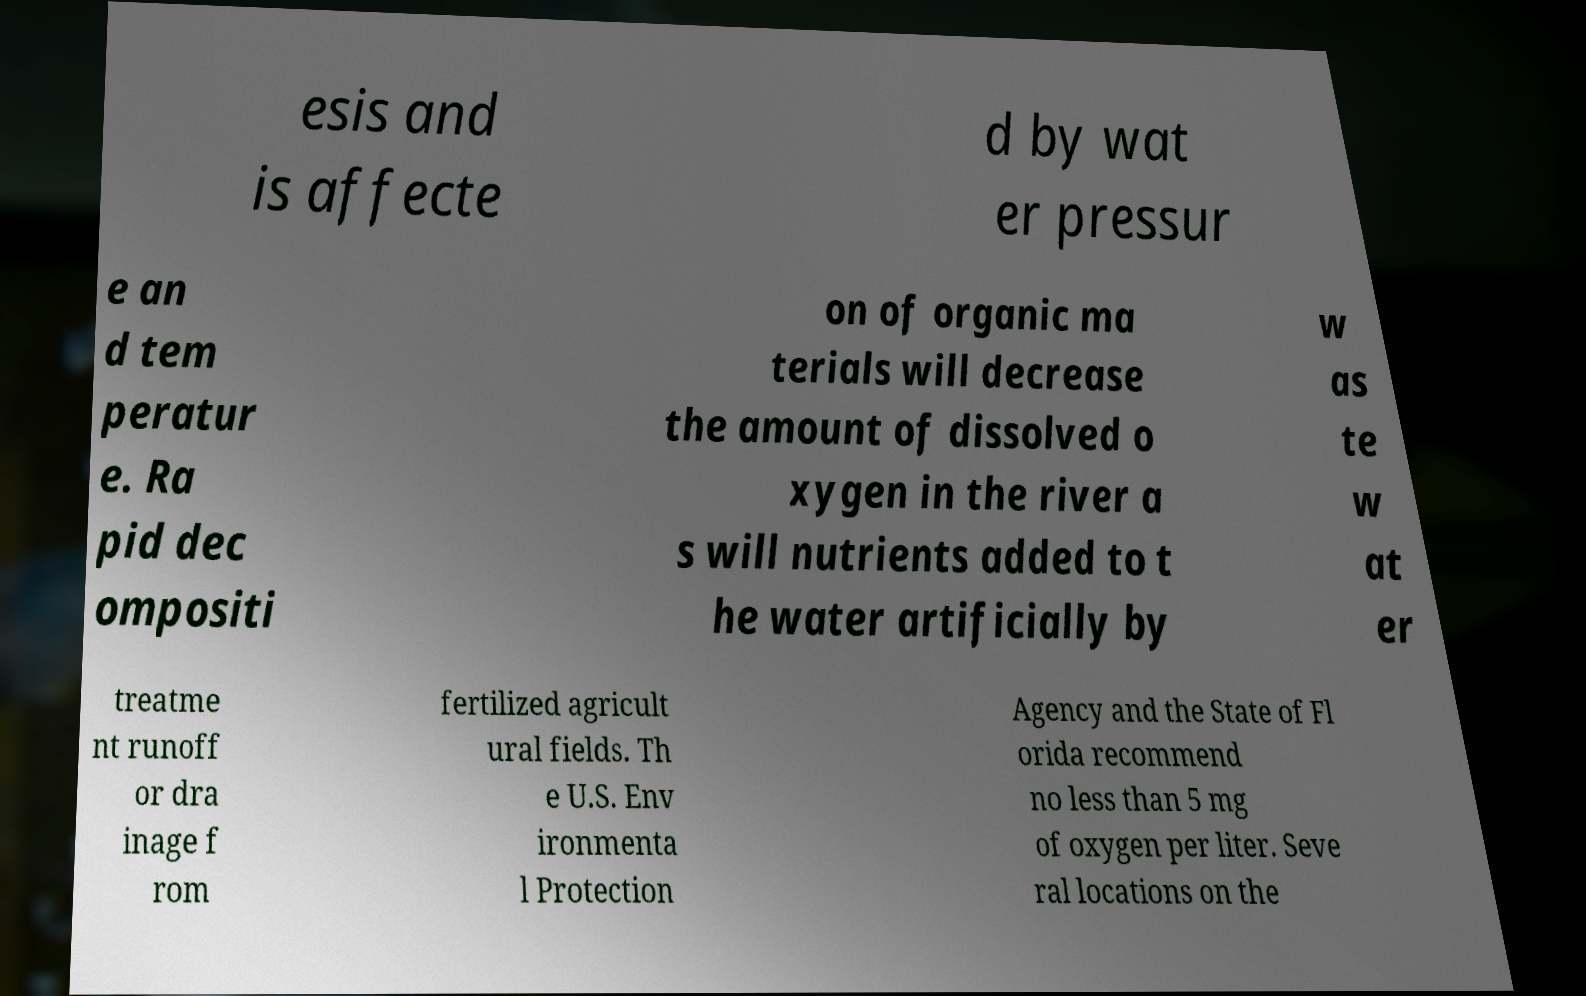I need the written content from this picture converted into text. Can you do that? esis and is affecte d by wat er pressur e an d tem peratur e. Ra pid dec ompositi on of organic ma terials will decrease the amount of dissolved o xygen in the river a s will nutrients added to t he water artificially by w as te w at er treatme nt runoff or dra inage f rom fertilized agricult ural fields. Th e U.S. Env ironmenta l Protection Agency and the State of Fl orida recommend no less than 5 mg of oxygen per liter. Seve ral locations on the 